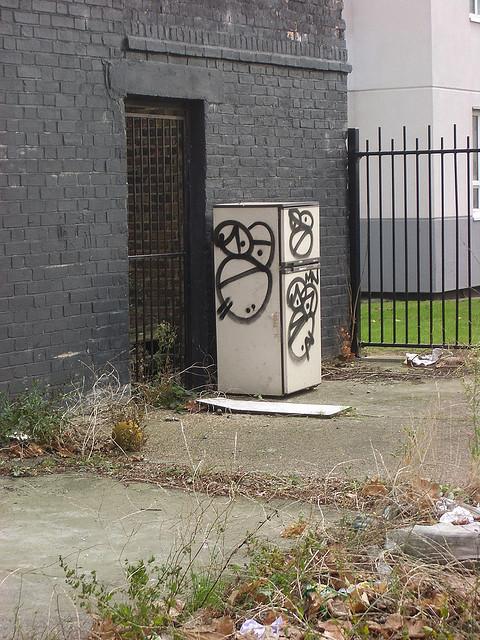Is graffiti considered a bad form of art?
Concise answer only. Yes. What color is the building?
Be succinct. Gray. What is the object that was spray painted?
Concise answer only. Refrigerator. 